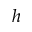Convert formula to latex. <formula><loc_0><loc_0><loc_500><loc_500>h</formula> 